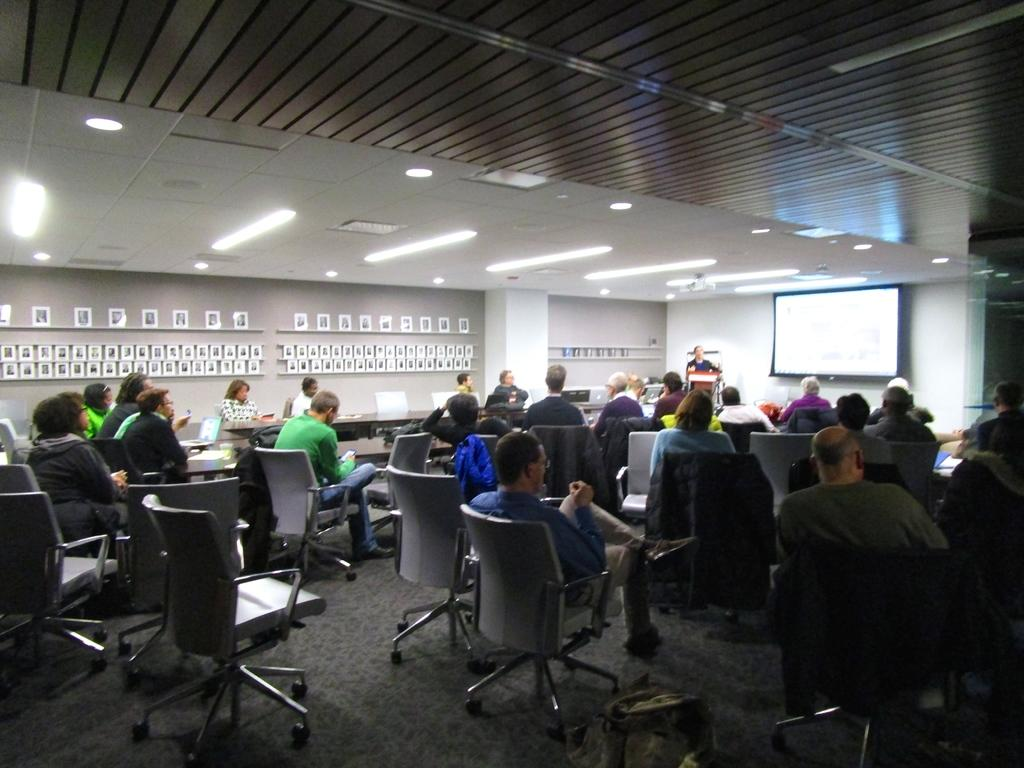What type of room is the image taken in? The image is taken in a conference room. What are the people in the image doing? There are persons sitting on chairs in the image. What can be seen on the wall in the background? There is a screen on the wall in the background. Can you describe the person standing in the background? A man is standing in the background. What type of kitten is playing with the current on the screen in the image? There is no kitten or current present on the screen in the image. How many twists are there in the chair that the person is sitting on in the image? The image does not provide enough detail to determine the number of twists in the chair. 